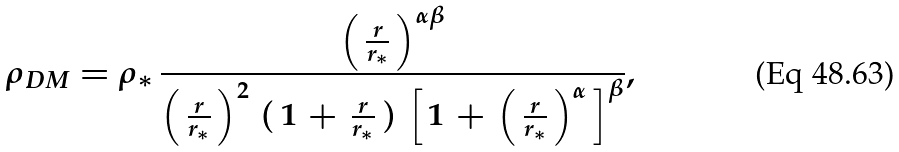Convert formula to latex. <formula><loc_0><loc_0><loc_500><loc_500>\rho _ { D M } = { \rho } _ { * } \, \frac { \left ( \, \frac { r } { r _ { * } } \, \right ) ^ { \alpha \beta } } { \left ( \, \frac { r } { r _ { * } } \, \right ) ^ { 2 } \, ( \, 1 \, + \, \frac { r } { r _ { * } } \, ) \, \left [ \, 1 \, + \, \left ( \, \frac { r } { r _ { * } } \, \right ) ^ { \alpha } \, \right ] ^ { \beta } } ,</formula> 